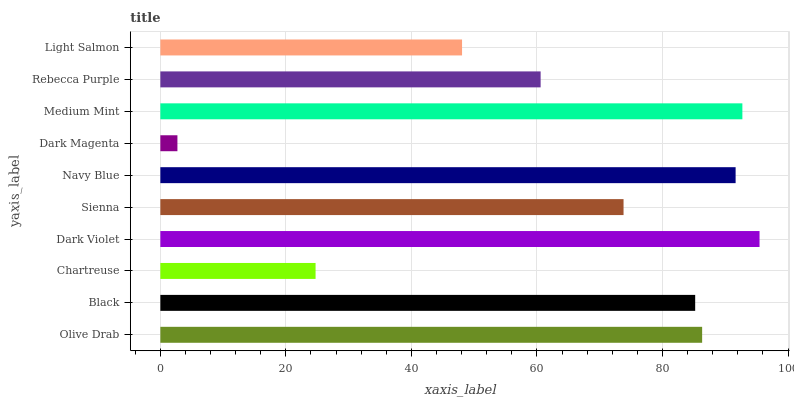Is Dark Magenta the minimum?
Answer yes or no. Yes. Is Dark Violet the maximum?
Answer yes or no. Yes. Is Black the minimum?
Answer yes or no. No. Is Black the maximum?
Answer yes or no. No. Is Olive Drab greater than Black?
Answer yes or no. Yes. Is Black less than Olive Drab?
Answer yes or no. Yes. Is Black greater than Olive Drab?
Answer yes or no. No. Is Olive Drab less than Black?
Answer yes or no. No. Is Black the high median?
Answer yes or no. Yes. Is Sienna the low median?
Answer yes or no. Yes. Is Dark Magenta the high median?
Answer yes or no. No. Is Rebecca Purple the low median?
Answer yes or no. No. 